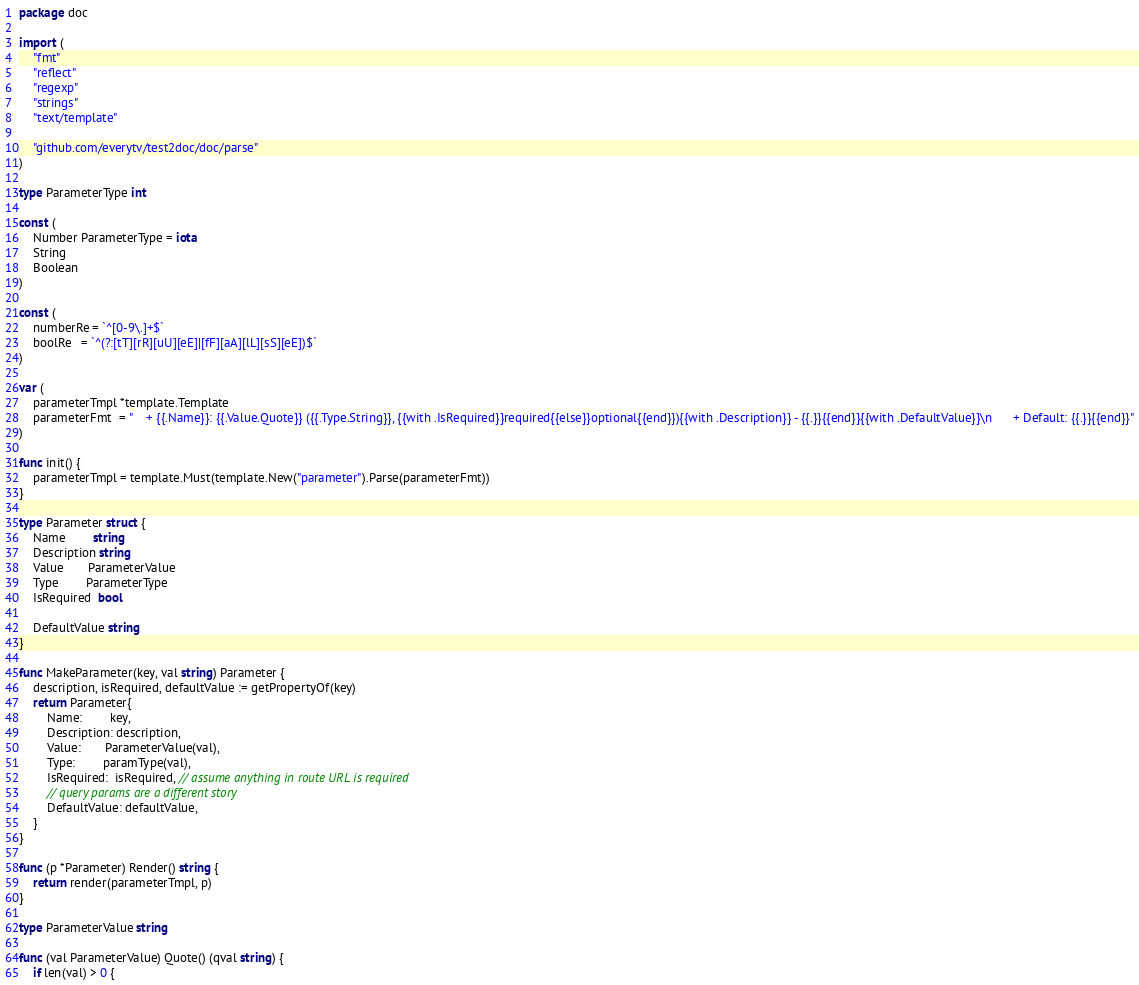Convert code to text. <code><loc_0><loc_0><loc_500><loc_500><_Go_>package doc

import (
	"fmt"
	"reflect"
	"regexp"
	"strings"
	"text/template"

	"github.com/everytv/test2doc/doc/parse"
)

type ParameterType int

const (
	Number ParameterType = iota
	String
	Boolean
)

const (
	numberRe = `^[0-9\.]+$`
	boolRe   = `^(?:[tT][rR][uU][eE]|[fF][aA][lL][sS][eE])$`
)

var (
	parameterTmpl *template.Template
	parameterFmt  = "    + {{.Name}}: {{.Value.Quote}} ({{.Type.String}}, {{with .IsRequired}}required{{else}}optional{{end}}){{with .Description}} - {{.}}{{end}}{{with .DefaultValue}}\n      + Default: {{.}}{{end}}"
)

func init() {
	parameterTmpl = template.Must(template.New("parameter").Parse(parameterFmt))
}

type Parameter struct {
	Name        string
	Description string
	Value       ParameterValue
	Type        ParameterType
	IsRequired  bool

	DefaultValue string
}

func MakeParameter(key, val string) Parameter {
	description, isRequired, defaultValue := getPropertyOf(key)
	return Parameter{
		Name:        key,
		Description: description,
		Value:       ParameterValue(val),
		Type:        paramType(val),
		IsRequired:  isRequired, // assume anything in route URL is required
		// query params are a different story
		DefaultValue: defaultValue,
	}
}

func (p *Parameter) Render() string {
	return render(parameterTmpl, p)
}

type ParameterValue string

func (val ParameterValue) Quote() (qval string) {
	if len(val) > 0 {</code> 